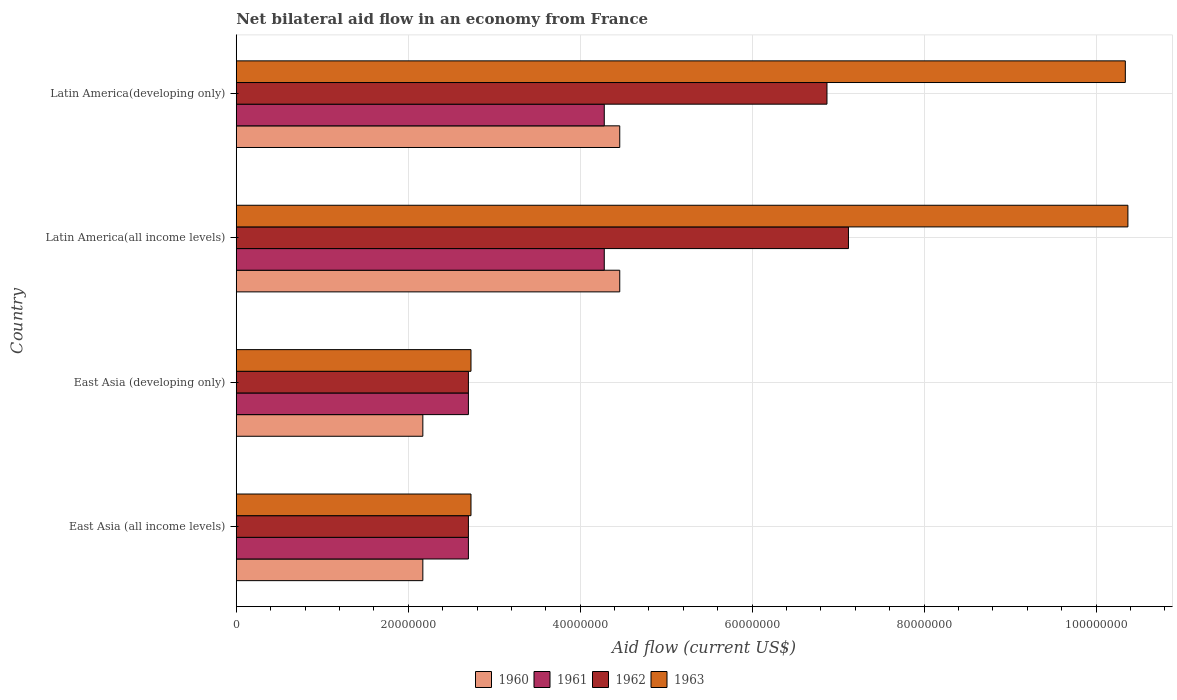How many groups of bars are there?
Your answer should be compact. 4. Are the number of bars per tick equal to the number of legend labels?
Keep it short and to the point. Yes. Are the number of bars on each tick of the Y-axis equal?
Your answer should be very brief. Yes. How many bars are there on the 2nd tick from the bottom?
Your answer should be very brief. 4. What is the label of the 1st group of bars from the top?
Your answer should be compact. Latin America(developing only). What is the net bilateral aid flow in 1960 in Latin America(developing only)?
Keep it short and to the point. 4.46e+07. Across all countries, what is the maximum net bilateral aid flow in 1961?
Give a very brief answer. 4.28e+07. Across all countries, what is the minimum net bilateral aid flow in 1961?
Your response must be concise. 2.70e+07. In which country was the net bilateral aid flow in 1962 maximum?
Provide a succinct answer. Latin America(all income levels). In which country was the net bilateral aid flow in 1961 minimum?
Ensure brevity in your answer.  East Asia (all income levels). What is the total net bilateral aid flow in 1961 in the graph?
Your answer should be compact. 1.40e+08. What is the difference between the net bilateral aid flow in 1961 in East Asia (all income levels) and that in Latin America(all income levels)?
Offer a very short reply. -1.58e+07. What is the difference between the net bilateral aid flow in 1963 in Latin America(all income levels) and the net bilateral aid flow in 1961 in East Asia (all income levels)?
Provide a succinct answer. 7.67e+07. What is the average net bilateral aid flow in 1961 per country?
Offer a terse response. 3.49e+07. What is the difference between the net bilateral aid flow in 1962 and net bilateral aid flow in 1960 in Latin America(all income levels)?
Give a very brief answer. 2.66e+07. In how many countries, is the net bilateral aid flow in 1960 greater than 72000000 US$?
Ensure brevity in your answer.  0. What is the ratio of the net bilateral aid flow in 1960 in East Asia (all income levels) to that in East Asia (developing only)?
Offer a very short reply. 1. What is the difference between the highest and the lowest net bilateral aid flow in 1960?
Your answer should be very brief. 2.29e+07. In how many countries, is the net bilateral aid flow in 1960 greater than the average net bilateral aid flow in 1960 taken over all countries?
Your response must be concise. 2. Is the sum of the net bilateral aid flow in 1961 in East Asia (developing only) and Latin America(all income levels) greater than the maximum net bilateral aid flow in 1960 across all countries?
Give a very brief answer. Yes. What does the 4th bar from the top in Latin America(all income levels) represents?
Ensure brevity in your answer.  1960. What does the 1st bar from the bottom in East Asia (all income levels) represents?
Provide a succinct answer. 1960. Is it the case that in every country, the sum of the net bilateral aid flow in 1960 and net bilateral aid flow in 1963 is greater than the net bilateral aid flow in 1962?
Keep it short and to the point. Yes. Are all the bars in the graph horizontal?
Provide a short and direct response. Yes. Are the values on the major ticks of X-axis written in scientific E-notation?
Offer a very short reply. No. Where does the legend appear in the graph?
Your response must be concise. Bottom center. How many legend labels are there?
Offer a terse response. 4. What is the title of the graph?
Ensure brevity in your answer.  Net bilateral aid flow in an economy from France. Does "2013" appear as one of the legend labels in the graph?
Provide a succinct answer. No. What is the label or title of the Y-axis?
Your answer should be compact. Country. What is the Aid flow (current US$) in 1960 in East Asia (all income levels)?
Offer a terse response. 2.17e+07. What is the Aid flow (current US$) in 1961 in East Asia (all income levels)?
Your response must be concise. 2.70e+07. What is the Aid flow (current US$) in 1962 in East Asia (all income levels)?
Offer a very short reply. 2.70e+07. What is the Aid flow (current US$) in 1963 in East Asia (all income levels)?
Give a very brief answer. 2.73e+07. What is the Aid flow (current US$) in 1960 in East Asia (developing only)?
Offer a terse response. 2.17e+07. What is the Aid flow (current US$) in 1961 in East Asia (developing only)?
Your response must be concise. 2.70e+07. What is the Aid flow (current US$) of 1962 in East Asia (developing only)?
Offer a very short reply. 2.70e+07. What is the Aid flow (current US$) in 1963 in East Asia (developing only)?
Keep it short and to the point. 2.73e+07. What is the Aid flow (current US$) in 1960 in Latin America(all income levels)?
Offer a very short reply. 4.46e+07. What is the Aid flow (current US$) of 1961 in Latin America(all income levels)?
Make the answer very short. 4.28e+07. What is the Aid flow (current US$) of 1962 in Latin America(all income levels)?
Offer a very short reply. 7.12e+07. What is the Aid flow (current US$) in 1963 in Latin America(all income levels)?
Your answer should be compact. 1.04e+08. What is the Aid flow (current US$) in 1960 in Latin America(developing only)?
Keep it short and to the point. 4.46e+07. What is the Aid flow (current US$) in 1961 in Latin America(developing only)?
Offer a very short reply. 4.28e+07. What is the Aid flow (current US$) of 1962 in Latin America(developing only)?
Your answer should be compact. 6.87e+07. What is the Aid flow (current US$) of 1963 in Latin America(developing only)?
Ensure brevity in your answer.  1.03e+08. Across all countries, what is the maximum Aid flow (current US$) in 1960?
Provide a succinct answer. 4.46e+07. Across all countries, what is the maximum Aid flow (current US$) in 1961?
Your response must be concise. 4.28e+07. Across all countries, what is the maximum Aid flow (current US$) of 1962?
Provide a succinct answer. 7.12e+07. Across all countries, what is the maximum Aid flow (current US$) of 1963?
Make the answer very short. 1.04e+08. Across all countries, what is the minimum Aid flow (current US$) of 1960?
Provide a succinct answer. 2.17e+07. Across all countries, what is the minimum Aid flow (current US$) of 1961?
Your answer should be very brief. 2.70e+07. Across all countries, what is the minimum Aid flow (current US$) of 1962?
Provide a short and direct response. 2.70e+07. Across all countries, what is the minimum Aid flow (current US$) in 1963?
Ensure brevity in your answer.  2.73e+07. What is the total Aid flow (current US$) of 1960 in the graph?
Make the answer very short. 1.33e+08. What is the total Aid flow (current US$) of 1961 in the graph?
Ensure brevity in your answer.  1.40e+08. What is the total Aid flow (current US$) in 1962 in the graph?
Provide a succinct answer. 1.94e+08. What is the total Aid flow (current US$) of 1963 in the graph?
Give a very brief answer. 2.62e+08. What is the difference between the Aid flow (current US$) in 1961 in East Asia (all income levels) and that in East Asia (developing only)?
Your response must be concise. 0. What is the difference between the Aid flow (current US$) of 1962 in East Asia (all income levels) and that in East Asia (developing only)?
Provide a short and direct response. 0. What is the difference between the Aid flow (current US$) of 1963 in East Asia (all income levels) and that in East Asia (developing only)?
Keep it short and to the point. 0. What is the difference between the Aid flow (current US$) in 1960 in East Asia (all income levels) and that in Latin America(all income levels)?
Give a very brief answer. -2.29e+07. What is the difference between the Aid flow (current US$) in 1961 in East Asia (all income levels) and that in Latin America(all income levels)?
Ensure brevity in your answer.  -1.58e+07. What is the difference between the Aid flow (current US$) in 1962 in East Asia (all income levels) and that in Latin America(all income levels)?
Your response must be concise. -4.42e+07. What is the difference between the Aid flow (current US$) in 1963 in East Asia (all income levels) and that in Latin America(all income levels)?
Your response must be concise. -7.64e+07. What is the difference between the Aid flow (current US$) of 1960 in East Asia (all income levels) and that in Latin America(developing only)?
Offer a terse response. -2.29e+07. What is the difference between the Aid flow (current US$) in 1961 in East Asia (all income levels) and that in Latin America(developing only)?
Provide a succinct answer. -1.58e+07. What is the difference between the Aid flow (current US$) in 1962 in East Asia (all income levels) and that in Latin America(developing only)?
Offer a very short reply. -4.17e+07. What is the difference between the Aid flow (current US$) in 1963 in East Asia (all income levels) and that in Latin America(developing only)?
Give a very brief answer. -7.61e+07. What is the difference between the Aid flow (current US$) in 1960 in East Asia (developing only) and that in Latin America(all income levels)?
Offer a terse response. -2.29e+07. What is the difference between the Aid flow (current US$) of 1961 in East Asia (developing only) and that in Latin America(all income levels)?
Provide a short and direct response. -1.58e+07. What is the difference between the Aid flow (current US$) of 1962 in East Asia (developing only) and that in Latin America(all income levels)?
Give a very brief answer. -4.42e+07. What is the difference between the Aid flow (current US$) in 1963 in East Asia (developing only) and that in Latin America(all income levels)?
Provide a short and direct response. -7.64e+07. What is the difference between the Aid flow (current US$) of 1960 in East Asia (developing only) and that in Latin America(developing only)?
Ensure brevity in your answer.  -2.29e+07. What is the difference between the Aid flow (current US$) in 1961 in East Asia (developing only) and that in Latin America(developing only)?
Provide a succinct answer. -1.58e+07. What is the difference between the Aid flow (current US$) in 1962 in East Asia (developing only) and that in Latin America(developing only)?
Ensure brevity in your answer.  -4.17e+07. What is the difference between the Aid flow (current US$) in 1963 in East Asia (developing only) and that in Latin America(developing only)?
Provide a short and direct response. -7.61e+07. What is the difference between the Aid flow (current US$) in 1962 in Latin America(all income levels) and that in Latin America(developing only)?
Offer a very short reply. 2.50e+06. What is the difference between the Aid flow (current US$) in 1960 in East Asia (all income levels) and the Aid flow (current US$) in 1961 in East Asia (developing only)?
Ensure brevity in your answer.  -5.30e+06. What is the difference between the Aid flow (current US$) of 1960 in East Asia (all income levels) and the Aid flow (current US$) of 1962 in East Asia (developing only)?
Your response must be concise. -5.30e+06. What is the difference between the Aid flow (current US$) of 1960 in East Asia (all income levels) and the Aid flow (current US$) of 1963 in East Asia (developing only)?
Your answer should be very brief. -5.60e+06. What is the difference between the Aid flow (current US$) of 1961 in East Asia (all income levels) and the Aid flow (current US$) of 1962 in East Asia (developing only)?
Keep it short and to the point. 0. What is the difference between the Aid flow (current US$) of 1962 in East Asia (all income levels) and the Aid flow (current US$) of 1963 in East Asia (developing only)?
Give a very brief answer. -3.00e+05. What is the difference between the Aid flow (current US$) in 1960 in East Asia (all income levels) and the Aid flow (current US$) in 1961 in Latin America(all income levels)?
Your answer should be very brief. -2.11e+07. What is the difference between the Aid flow (current US$) of 1960 in East Asia (all income levels) and the Aid flow (current US$) of 1962 in Latin America(all income levels)?
Give a very brief answer. -4.95e+07. What is the difference between the Aid flow (current US$) in 1960 in East Asia (all income levels) and the Aid flow (current US$) in 1963 in Latin America(all income levels)?
Ensure brevity in your answer.  -8.20e+07. What is the difference between the Aid flow (current US$) in 1961 in East Asia (all income levels) and the Aid flow (current US$) in 1962 in Latin America(all income levels)?
Keep it short and to the point. -4.42e+07. What is the difference between the Aid flow (current US$) in 1961 in East Asia (all income levels) and the Aid flow (current US$) in 1963 in Latin America(all income levels)?
Keep it short and to the point. -7.67e+07. What is the difference between the Aid flow (current US$) of 1962 in East Asia (all income levels) and the Aid flow (current US$) of 1963 in Latin America(all income levels)?
Offer a very short reply. -7.67e+07. What is the difference between the Aid flow (current US$) in 1960 in East Asia (all income levels) and the Aid flow (current US$) in 1961 in Latin America(developing only)?
Your response must be concise. -2.11e+07. What is the difference between the Aid flow (current US$) in 1960 in East Asia (all income levels) and the Aid flow (current US$) in 1962 in Latin America(developing only)?
Ensure brevity in your answer.  -4.70e+07. What is the difference between the Aid flow (current US$) in 1960 in East Asia (all income levels) and the Aid flow (current US$) in 1963 in Latin America(developing only)?
Offer a terse response. -8.17e+07. What is the difference between the Aid flow (current US$) of 1961 in East Asia (all income levels) and the Aid flow (current US$) of 1962 in Latin America(developing only)?
Your answer should be very brief. -4.17e+07. What is the difference between the Aid flow (current US$) of 1961 in East Asia (all income levels) and the Aid flow (current US$) of 1963 in Latin America(developing only)?
Provide a short and direct response. -7.64e+07. What is the difference between the Aid flow (current US$) in 1962 in East Asia (all income levels) and the Aid flow (current US$) in 1963 in Latin America(developing only)?
Provide a succinct answer. -7.64e+07. What is the difference between the Aid flow (current US$) of 1960 in East Asia (developing only) and the Aid flow (current US$) of 1961 in Latin America(all income levels)?
Your answer should be very brief. -2.11e+07. What is the difference between the Aid flow (current US$) in 1960 in East Asia (developing only) and the Aid flow (current US$) in 1962 in Latin America(all income levels)?
Make the answer very short. -4.95e+07. What is the difference between the Aid flow (current US$) in 1960 in East Asia (developing only) and the Aid flow (current US$) in 1963 in Latin America(all income levels)?
Keep it short and to the point. -8.20e+07. What is the difference between the Aid flow (current US$) in 1961 in East Asia (developing only) and the Aid flow (current US$) in 1962 in Latin America(all income levels)?
Ensure brevity in your answer.  -4.42e+07. What is the difference between the Aid flow (current US$) in 1961 in East Asia (developing only) and the Aid flow (current US$) in 1963 in Latin America(all income levels)?
Provide a short and direct response. -7.67e+07. What is the difference between the Aid flow (current US$) in 1962 in East Asia (developing only) and the Aid flow (current US$) in 1963 in Latin America(all income levels)?
Provide a short and direct response. -7.67e+07. What is the difference between the Aid flow (current US$) in 1960 in East Asia (developing only) and the Aid flow (current US$) in 1961 in Latin America(developing only)?
Ensure brevity in your answer.  -2.11e+07. What is the difference between the Aid flow (current US$) of 1960 in East Asia (developing only) and the Aid flow (current US$) of 1962 in Latin America(developing only)?
Keep it short and to the point. -4.70e+07. What is the difference between the Aid flow (current US$) in 1960 in East Asia (developing only) and the Aid flow (current US$) in 1963 in Latin America(developing only)?
Make the answer very short. -8.17e+07. What is the difference between the Aid flow (current US$) of 1961 in East Asia (developing only) and the Aid flow (current US$) of 1962 in Latin America(developing only)?
Ensure brevity in your answer.  -4.17e+07. What is the difference between the Aid flow (current US$) of 1961 in East Asia (developing only) and the Aid flow (current US$) of 1963 in Latin America(developing only)?
Give a very brief answer. -7.64e+07. What is the difference between the Aid flow (current US$) in 1962 in East Asia (developing only) and the Aid flow (current US$) in 1963 in Latin America(developing only)?
Provide a succinct answer. -7.64e+07. What is the difference between the Aid flow (current US$) in 1960 in Latin America(all income levels) and the Aid flow (current US$) in 1961 in Latin America(developing only)?
Make the answer very short. 1.80e+06. What is the difference between the Aid flow (current US$) in 1960 in Latin America(all income levels) and the Aid flow (current US$) in 1962 in Latin America(developing only)?
Ensure brevity in your answer.  -2.41e+07. What is the difference between the Aid flow (current US$) of 1960 in Latin America(all income levels) and the Aid flow (current US$) of 1963 in Latin America(developing only)?
Ensure brevity in your answer.  -5.88e+07. What is the difference between the Aid flow (current US$) of 1961 in Latin America(all income levels) and the Aid flow (current US$) of 1962 in Latin America(developing only)?
Ensure brevity in your answer.  -2.59e+07. What is the difference between the Aid flow (current US$) in 1961 in Latin America(all income levels) and the Aid flow (current US$) in 1963 in Latin America(developing only)?
Keep it short and to the point. -6.06e+07. What is the difference between the Aid flow (current US$) in 1962 in Latin America(all income levels) and the Aid flow (current US$) in 1963 in Latin America(developing only)?
Provide a succinct answer. -3.22e+07. What is the average Aid flow (current US$) of 1960 per country?
Keep it short and to the point. 3.32e+07. What is the average Aid flow (current US$) in 1961 per country?
Make the answer very short. 3.49e+07. What is the average Aid flow (current US$) of 1962 per country?
Ensure brevity in your answer.  4.85e+07. What is the average Aid flow (current US$) in 1963 per country?
Provide a short and direct response. 6.54e+07. What is the difference between the Aid flow (current US$) in 1960 and Aid flow (current US$) in 1961 in East Asia (all income levels)?
Your answer should be very brief. -5.30e+06. What is the difference between the Aid flow (current US$) in 1960 and Aid flow (current US$) in 1962 in East Asia (all income levels)?
Keep it short and to the point. -5.30e+06. What is the difference between the Aid flow (current US$) of 1960 and Aid flow (current US$) of 1963 in East Asia (all income levels)?
Keep it short and to the point. -5.60e+06. What is the difference between the Aid flow (current US$) in 1961 and Aid flow (current US$) in 1963 in East Asia (all income levels)?
Give a very brief answer. -3.00e+05. What is the difference between the Aid flow (current US$) in 1960 and Aid flow (current US$) in 1961 in East Asia (developing only)?
Your answer should be compact. -5.30e+06. What is the difference between the Aid flow (current US$) in 1960 and Aid flow (current US$) in 1962 in East Asia (developing only)?
Give a very brief answer. -5.30e+06. What is the difference between the Aid flow (current US$) of 1960 and Aid flow (current US$) of 1963 in East Asia (developing only)?
Your answer should be compact. -5.60e+06. What is the difference between the Aid flow (current US$) in 1961 and Aid flow (current US$) in 1962 in East Asia (developing only)?
Your answer should be compact. 0. What is the difference between the Aid flow (current US$) in 1961 and Aid flow (current US$) in 1963 in East Asia (developing only)?
Your response must be concise. -3.00e+05. What is the difference between the Aid flow (current US$) in 1962 and Aid flow (current US$) in 1963 in East Asia (developing only)?
Make the answer very short. -3.00e+05. What is the difference between the Aid flow (current US$) in 1960 and Aid flow (current US$) in 1961 in Latin America(all income levels)?
Your response must be concise. 1.80e+06. What is the difference between the Aid flow (current US$) of 1960 and Aid flow (current US$) of 1962 in Latin America(all income levels)?
Your answer should be very brief. -2.66e+07. What is the difference between the Aid flow (current US$) of 1960 and Aid flow (current US$) of 1963 in Latin America(all income levels)?
Offer a very short reply. -5.91e+07. What is the difference between the Aid flow (current US$) of 1961 and Aid flow (current US$) of 1962 in Latin America(all income levels)?
Provide a short and direct response. -2.84e+07. What is the difference between the Aid flow (current US$) in 1961 and Aid flow (current US$) in 1963 in Latin America(all income levels)?
Provide a succinct answer. -6.09e+07. What is the difference between the Aid flow (current US$) of 1962 and Aid flow (current US$) of 1963 in Latin America(all income levels)?
Offer a terse response. -3.25e+07. What is the difference between the Aid flow (current US$) of 1960 and Aid flow (current US$) of 1961 in Latin America(developing only)?
Offer a terse response. 1.80e+06. What is the difference between the Aid flow (current US$) in 1960 and Aid flow (current US$) in 1962 in Latin America(developing only)?
Provide a succinct answer. -2.41e+07. What is the difference between the Aid flow (current US$) of 1960 and Aid flow (current US$) of 1963 in Latin America(developing only)?
Ensure brevity in your answer.  -5.88e+07. What is the difference between the Aid flow (current US$) in 1961 and Aid flow (current US$) in 1962 in Latin America(developing only)?
Provide a short and direct response. -2.59e+07. What is the difference between the Aid flow (current US$) of 1961 and Aid flow (current US$) of 1963 in Latin America(developing only)?
Offer a very short reply. -6.06e+07. What is the difference between the Aid flow (current US$) of 1962 and Aid flow (current US$) of 1963 in Latin America(developing only)?
Offer a terse response. -3.47e+07. What is the ratio of the Aid flow (current US$) in 1960 in East Asia (all income levels) to that in East Asia (developing only)?
Offer a terse response. 1. What is the ratio of the Aid flow (current US$) of 1961 in East Asia (all income levels) to that in East Asia (developing only)?
Offer a terse response. 1. What is the ratio of the Aid flow (current US$) in 1962 in East Asia (all income levels) to that in East Asia (developing only)?
Your answer should be very brief. 1. What is the ratio of the Aid flow (current US$) of 1960 in East Asia (all income levels) to that in Latin America(all income levels)?
Offer a terse response. 0.49. What is the ratio of the Aid flow (current US$) in 1961 in East Asia (all income levels) to that in Latin America(all income levels)?
Your answer should be compact. 0.63. What is the ratio of the Aid flow (current US$) in 1962 in East Asia (all income levels) to that in Latin America(all income levels)?
Give a very brief answer. 0.38. What is the ratio of the Aid flow (current US$) of 1963 in East Asia (all income levels) to that in Latin America(all income levels)?
Give a very brief answer. 0.26. What is the ratio of the Aid flow (current US$) of 1960 in East Asia (all income levels) to that in Latin America(developing only)?
Give a very brief answer. 0.49. What is the ratio of the Aid flow (current US$) of 1961 in East Asia (all income levels) to that in Latin America(developing only)?
Give a very brief answer. 0.63. What is the ratio of the Aid flow (current US$) in 1962 in East Asia (all income levels) to that in Latin America(developing only)?
Provide a short and direct response. 0.39. What is the ratio of the Aid flow (current US$) in 1963 in East Asia (all income levels) to that in Latin America(developing only)?
Your response must be concise. 0.26. What is the ratio of the Aid flow (current US$) of 1960 in East Asia (developing only) to that in Latin America(all income levels)?
Keep it short and to the point. 0.49. What is the ratio of the Aid flow (current US$) in 1961 in East Asia (developing only) to that in Latin America(all income levels)?
Offer a terse response. 0.63. What is the ratio of the Aid flow (current US$) in 1962 in East Asia (developing only) to that in Latin America(all income levels)?
Provide a short and direct response. 0.38. What is the ratio of the Aid flow (current US$) in 1963 in East Asia (developing only) to that in Latin America(all income levels)?
Offer a very short reply. 0.26. What is the ratio of the Aid flow (current US$) in 1960 in East Asia (developing only) to that in Latin America(developing only)?
Give a very brief answer. 0.49. What is the ratio of the Aid flow (current US$) in 1961 in East Asia (developing only) to that in Latin America(developing only)?
Your response must be concise. 0.63. What is the ratio of the Aid flow (current US$) in 1962 in East Asia (developing only) to that in Latin America(developing only)?
Give a very brief answer. 0.39. What is the ratio of the Aid flow (current US$) in 1963 in East Asia (developing only) to that in Latin America(developing only)?
Provide a short and direct response. 0.26. What is the ratio of the Aid flow (current US$) in 1961 in Latin America(all income levels) to that in Latin America(developing only)?
Make the answer very short. 1. What is the ratio of the Aid flow (current US$) in 1962 in Latin America(all income levels) to that in Latin America(developing only)?
Offer a terse response. 1.04. What is the ratio of the Aid flow (current US$) in 1963 in Latin America(all income levels) to that in Latin America(developing only)?
Provide a succinct answer. 1. What is the difference between the highest and the second highest Aid flow (current US$) in 1960?
Make the answer very short. 0. What is the difference between the highest and the second highest Aid flow (current US$) in 1961?
Offer a terse response. 0. What is the difference between the highest and the second highest Aid flow (current US$) of 1962?
Provide a succinct answer. 2.50e+06. What is the difference between the highest and the lowest Aid flow (current US$) of 1960?
Give a very brief answer. 2.29e+07. What is the difference between the highest and the lowest Aid flow (current US$) of 1961?
Provide a short and direct response. 1.58e+07. What is the difference between the highest and the lowest Aid flow (current US$) of 1962?
Your answer should be very brief. 4.42e+07. What is the difference between the highest and the lowest Aid flow (current US$) of 1963?
Keep it short and to the point. 7.64e+07. 